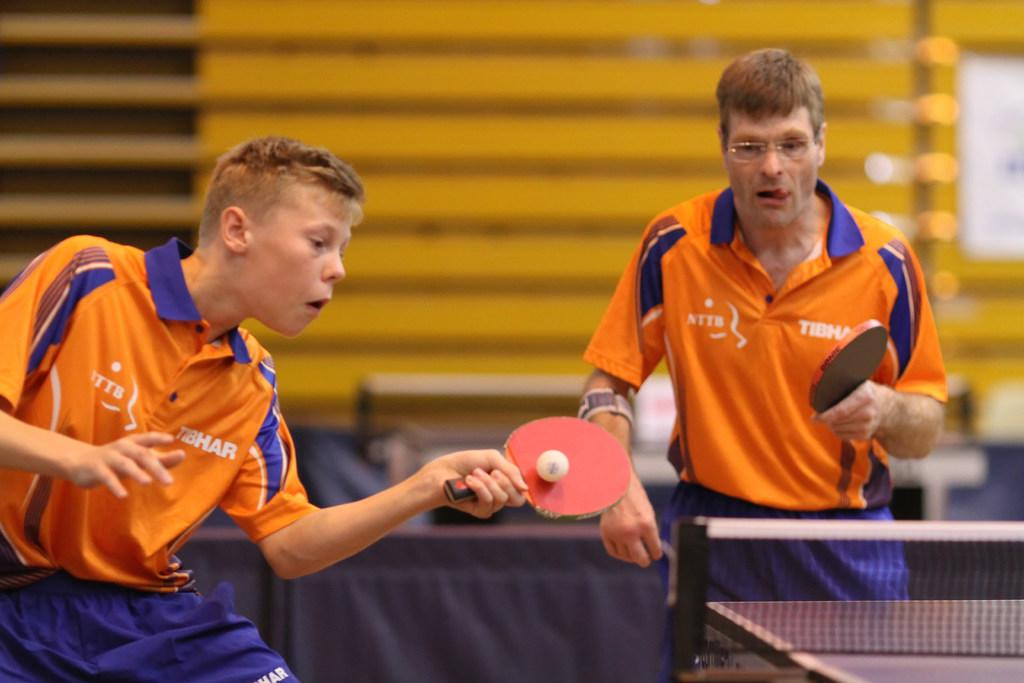How many people are in the image? There are two persons in the image. What are the persons holding in their hands? The persons are holding rackets. Is there a ball visible in the image? Yes, there is a ball on one of the rackets. What sport are the persons playing in the image? The game being played is table tennis. What sense is being used by the yak in the image? There is no yak present in the image, so it is not possible to determine which sense is being used. 